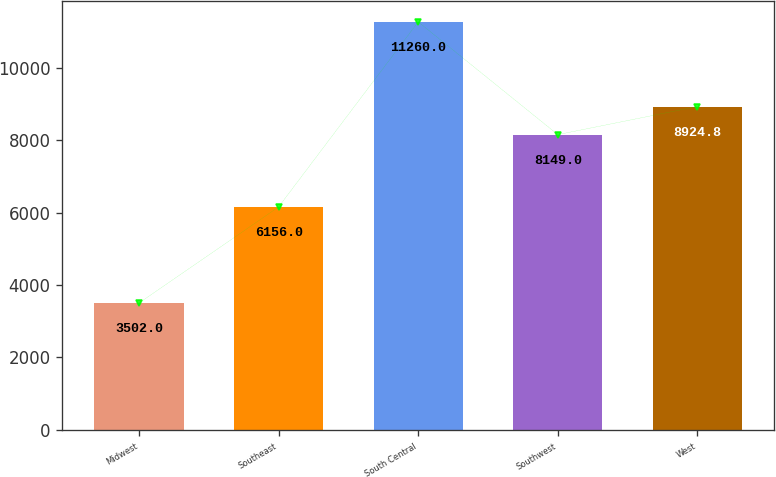Convert chart to OTSL. <chart><loc_0><loc_0><loc_500><loc_500><bar_chart><fcel>Midwest<fcel>Southeast<fcel>South Central<fcel>Southwest<fcel>West<nl><fcel>3502<fcel>6156<fcel>11260<fcel>8149<fcel>8924.8<nl></chart> 